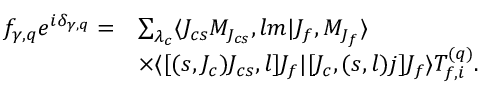Convert formula to latex. <formula><loc_0><loc_0><loc_500><loc_500>\begin{array} { r l } { f _ { \gamma , q } e ^ { i \delta _ { \gamma , q } } = } & { \sum _ { \lambda _ { c } } \langle J _ { c s } M _ { J _ { c s } } , l m | J _ { f } , M _ { J _ { f } } \rangle } \\ & { \times \langle [ ( s , J _ { c } ) J _ { c s } , l ] J _ { f } | [ J _ { c } , ( s , l ) j ] J _ { f } \rangle T _ { f , i } ^ { ( q ) } . } \end{array}</formula> 